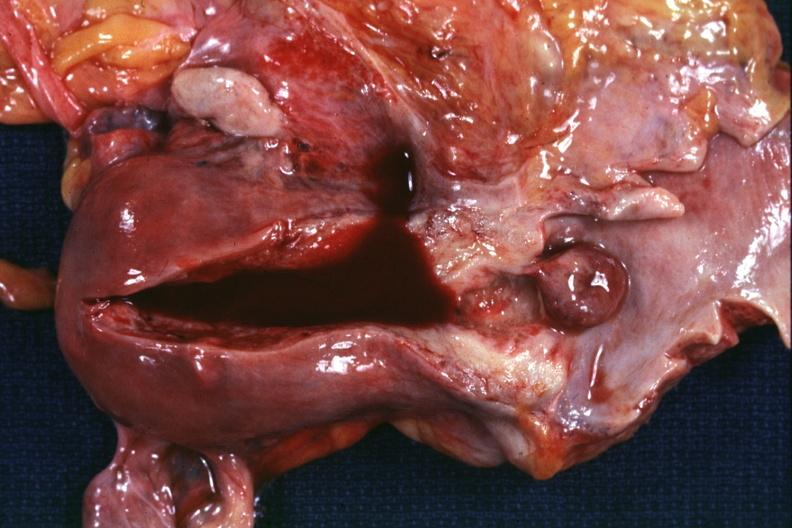s normal immature infant present?
Answer the question using a single word or phrase. No 